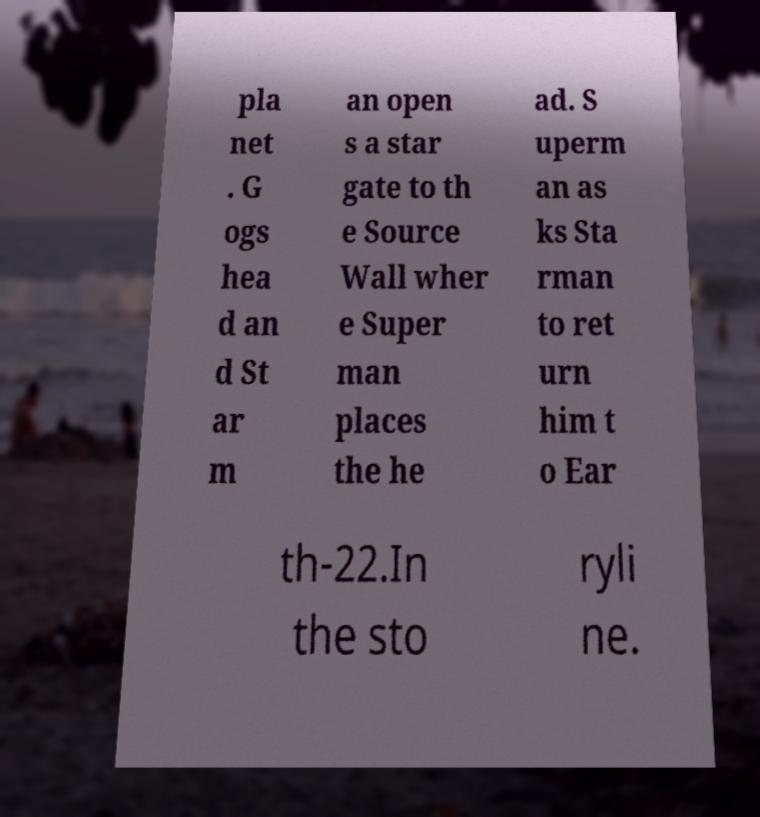There's text embedded in this image that I need extracted. Can you transcribe it verbatim? pla net . G ogs hea d an d St ar m an open s a star gate to th e Source Wall wher e Super man places the he ad. S uperm an as ks Sta rman to ret urn him t o Ear th-22.In the sto ryli ne. 